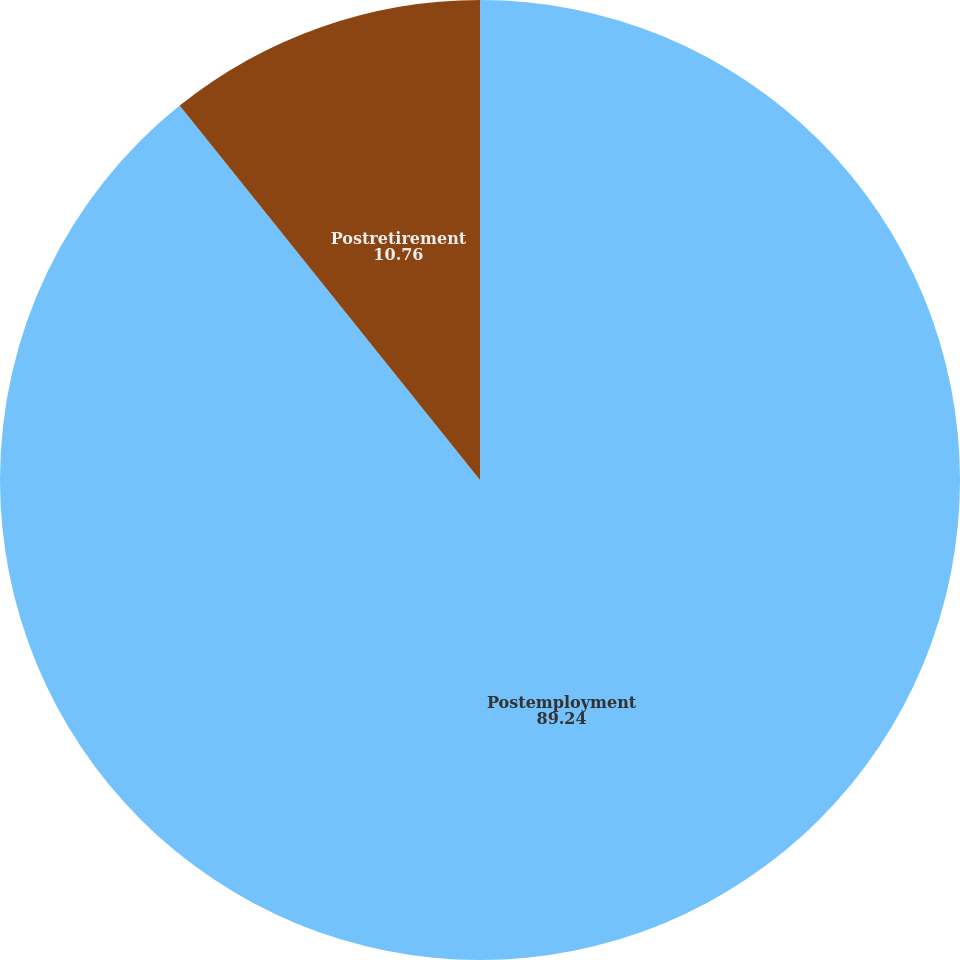Convert chart to OTSL. <chart><loc_0><loc_0><loc_500><loc_500><pie_chart><fcel>Postemployment<fcel>Postretirement<nl><fcel>89.24%<fcel>10.76%<nl></chart> 